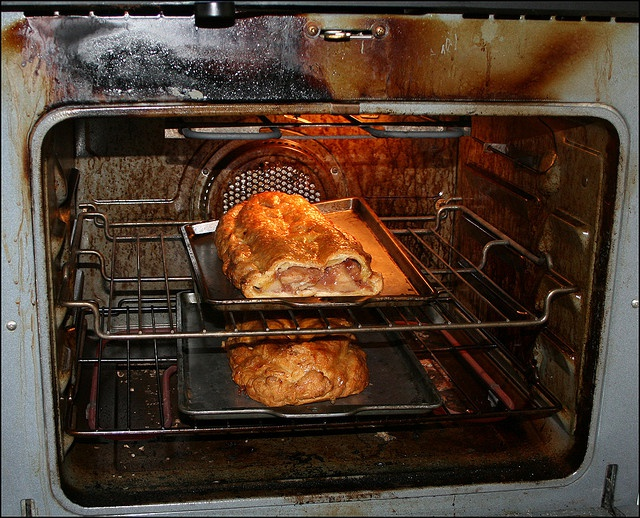Describe the objects in this image and their specific colors. I can see a oven in black, maroon, gray, and darkgray tones in this image. 